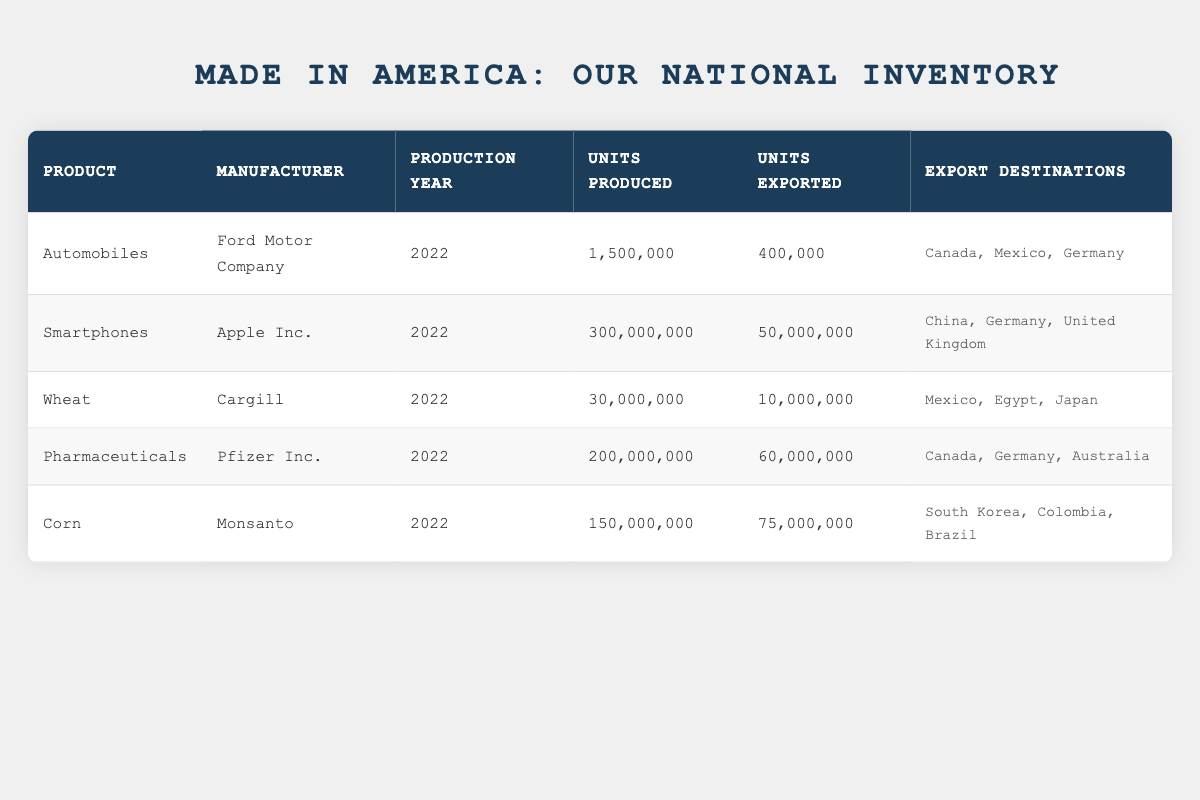What is the total number of units produced for all products in the table? To find the total units produced, we add the units produced for each product: 1,500,000 (Automobiles) + 300,000,000 (Smartphones) + 30,000,000 (Wheat) + 200,000,000 (Pharmaceuticals) + 150,000,000 (Corn) = 681,500,000.
Answer: 681,500,000 Which product had the highest number of units exported in 2022? By checking the units exported for each product, we see that Corn had 75,000,000 units exported, more than any other product: 400,000 (Automobiles), 50,000,000 (Smartphones), 10,000,000 (Wheat), and 60,000,000 (Pharmaceuticals).
Answer: Corn Did Ford Motor Company export more than 500,000 units in 2022? Ford Motor Company exported 400,000 units of automobiles in 2022. Since 400,000 is less than 500,000, the statement is false.
Answer: No How many countries received pharmaceuticals from the United States in 2022? The table shows that pharmaceuticals were exported to Canada, Germany, and Australia. Thus, there are three countries in total.
Answer: 3 What percentage of the total units produced were exported for all products combined? First, we calculate the total units exported: 400,000 + 50,000,000 + 10,000,000 + 60,000,000 + 75,000,000 = 195,450,000. The percentage is then calculated as (195,450,000 / 681,500,000) * 100, which equals approximately 28.7%.
Answer: 28.7% Are Apple Inc.'s export destinations all in Europe? The export destinations for Apple Inc. are China, Germany, and the United Kingdom. Since China is not in Europe, the statement is false.
Answer: No What is the difference between the units produced for smartphones and wheat? The units produced for smartphones is 300,000,000 and for wheat is 30,000,000. The difference is calculated as 300,000,000 - 30,000,000 = 270,000,000.
Answer: 270,000,000 Which product has the lowest units produced and what is the number? By reviewing the units produced, we see that Wheat has the lowest with 30,000,000 units. Comparing with the others: Automobiles (1,500,000), Smartphones (300,000,000), Pharmaceuticals (200,000,000), Corn (150,000,000), confirms Wheat's lowest production.
Answer: Wheat, 30,000,000 How many units of corn were exported to Brazil? The table shows that corn was exported to South Korea, Colombia, and Brazil but does not specify the number of units sent to Brazil. Therefore, we cannot determine the number.
Answer: Not specified 